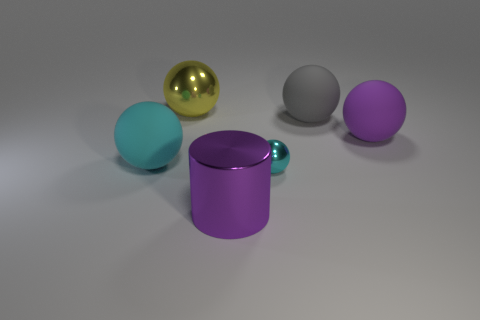Add 2 tiny blue shiny cylinders. How many objects exist? 8 Subtract all large purple balls. How many balls are left? 4 Subtract 4 spheres. How many spheres are left? 1 Subtract all green cubes. How many cyan balls are left? 2 Subtract all gray spheres. How many spheres are left? 4 Subtract all balls. How many objects are left? 1 Subtract all large purple balls. Subtract all large yellow objects. How many objects are left? 4 Add 3 tiny cyan metallic balls. How many tiny cyan metallic balls are left? 4 Add 2 large blue objects. How many large blue objects exist? 2 Subtract 2 cyan spheres. How many objects are left? 4 